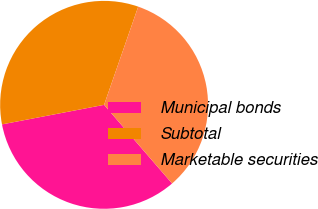Convert chart to OTSL. <chart><loc_0><loc_0><loc_500><loc_500><pie_chart><fcel>Municipal bonds<fcel>Subtotal<fcel>Marketable securities<nl><fcel>33.33%<fcel>33.33%<fcel>33.33%<nl></chart> 